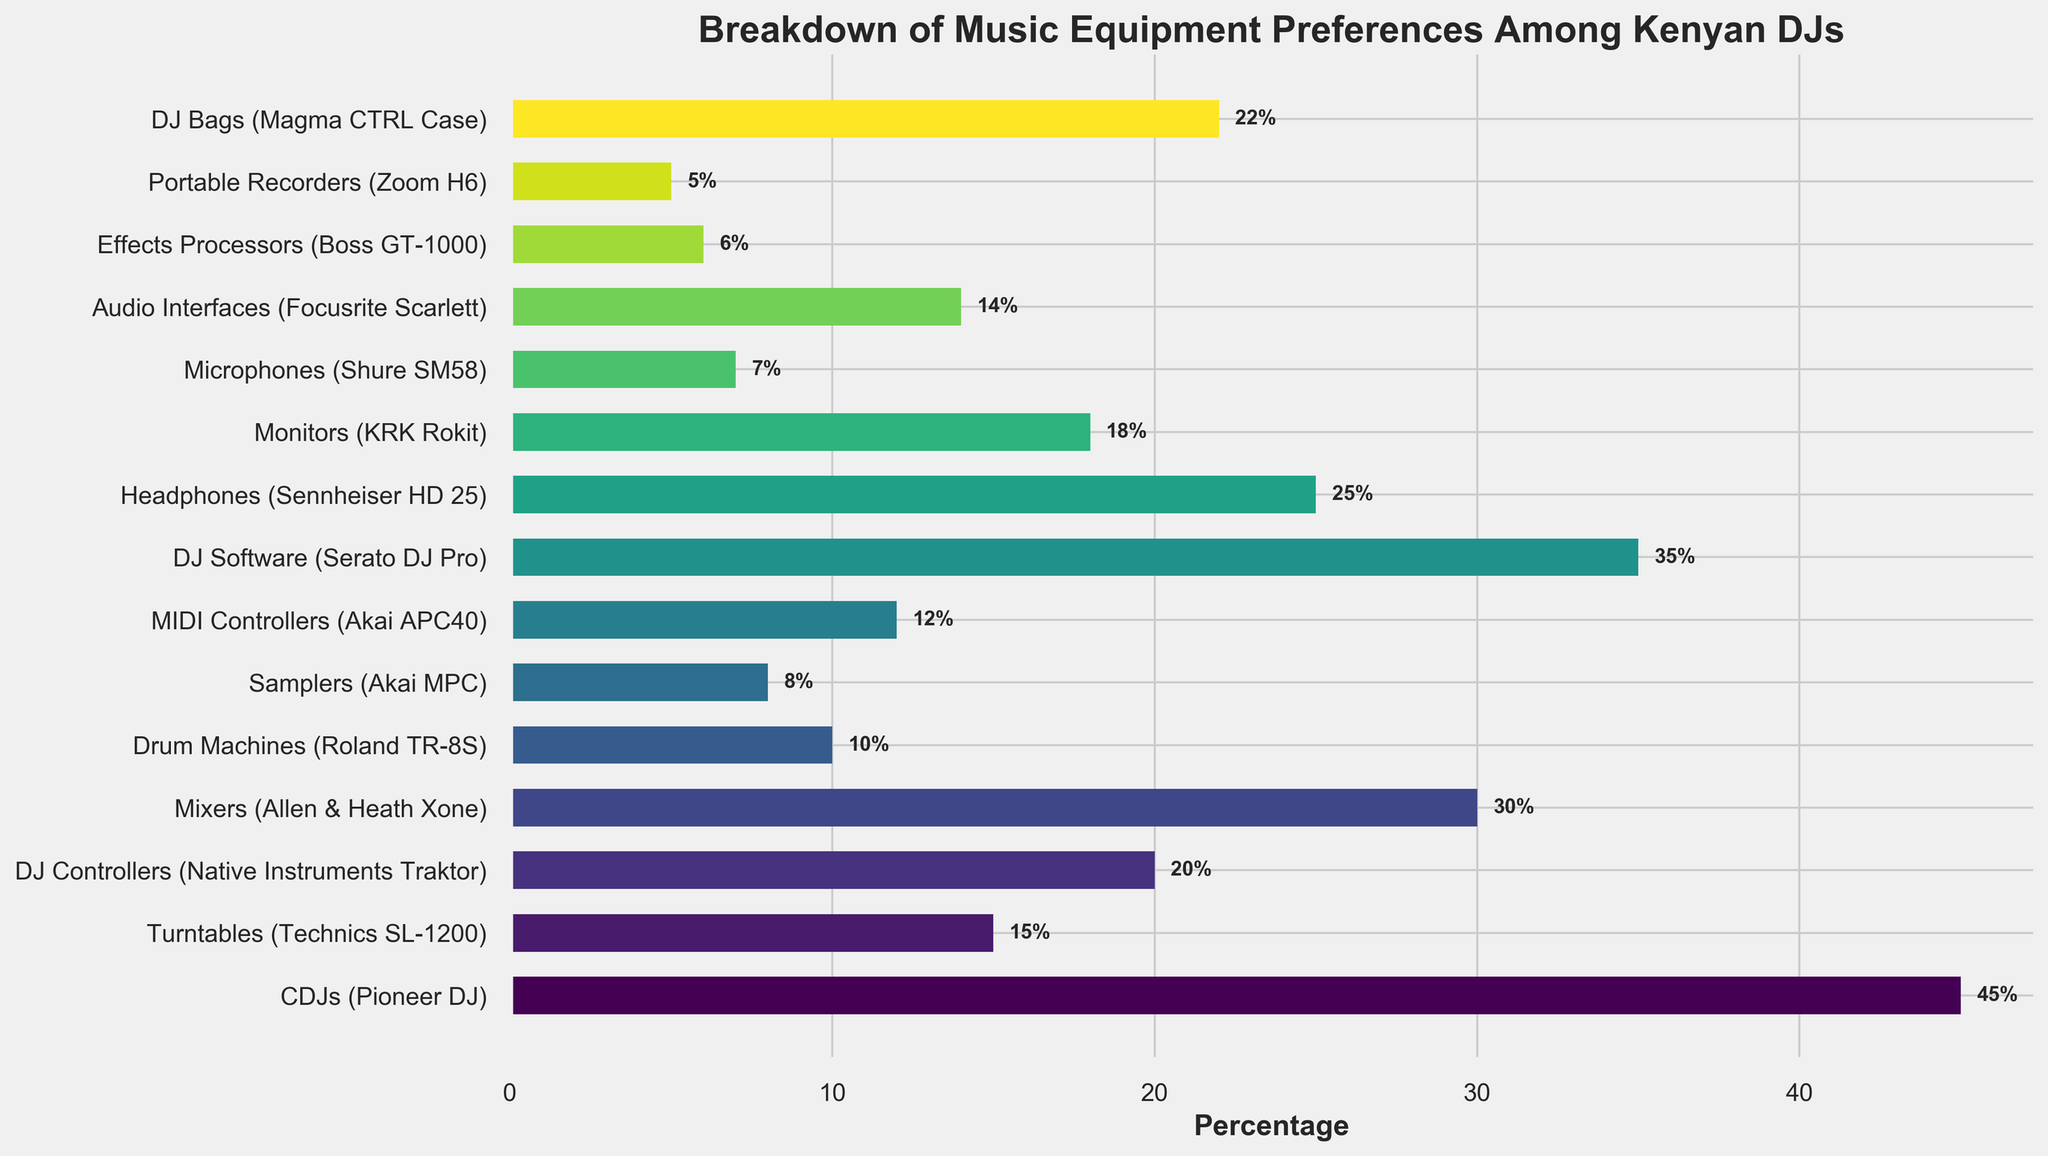What's the most preferred music equipment among Kenyan DJs? The bar chart shows various types of music equipment and their respective percentages of preference. The highest percentage indicates the most preferred equipment.
Answer: CDJs (Pioneer DJ) Which equipment is less popular, Drum Machines or Audio Interfaces? Compare the percentages of Drum Machines and Audio Interfaces from the chart. Drum Machines have a preference of 10%, while Audio Interfaces have 14%. Thus, Drum Machines are less popular.
Answer: Drum Machines What is the total percentage of preferences for Mixers and DJ Controllers combined? Add the percentages for Mixers (30%) and DJ Controllers (20%). The sum of these two percentages gives the combined preference.
Answer: 50% Which equipment category lies exactly between the percentages of Monitors and MIDI Controllers? Look at the percentages for Monitors (18%) and MIDI Controllers (12%). Find the category whose percentage lies between these values.
Answer: DJ Bags (22%) Are Samplers or Effects Processors more preferred by Kenyan DJs? Compare the percentages of Samplers (8%) and Effects Processors (6%). Samplers have a higher percentage of preference.
Answer: Samplers How many types of equipment have a preference of 20% or more? Identify the categories with percentages 20% or higher: CDJs (45%), Mixers (30%), DJ Software (35%), DJ Controllers (20%), and DJ Bags (22%). There are five categories in total.
Answer: Five What's the difference in preference between Turntables and Headphones? Subtract the percentage of Turntables (15%) from that of Headphones (25%).
Answer: 10% Which equipment type has the closest preference percentage to DJ Software? Look for equipment types closest to DJ Software’s 35%. CDJs with 45% is the nearest.
Answer: CDJs What's the combined preference percentage for DJ Software, Headphones, and DJ Bags? Add the percentages for DJ Software (35%), Headphones (25%), and DJ Bags (22%). The sum is 35 + 25 + 22.
Answer: 82% Is the percentage preference for Microphones higher or lower compared to Portable Recorders? Compare the percentages directly from the chart: Microphones have 7%, while Portable Recorders have 5%. Thus, Microphones have a higher preference.
Answer: Higher 